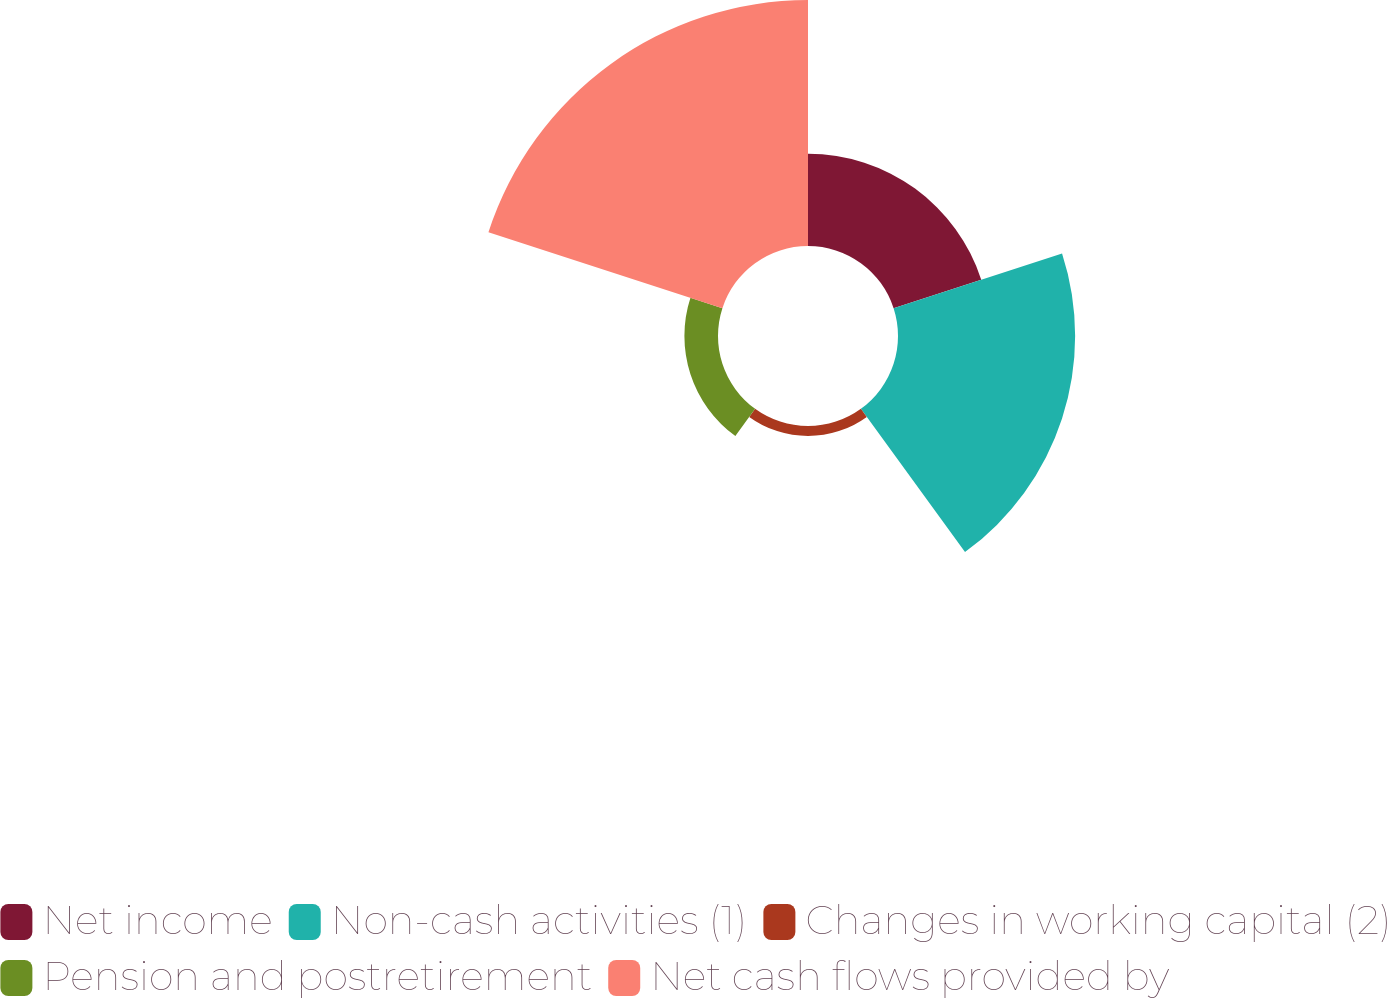<chart> <loc_0><loc_0><loc_500><loc_500><pie_chart><fcel>Net income<fcel>Non-cash activities (1)<fcel>Changes in working capital (2)<fcel>Pension and postretirement<fcel>Net cash flows provided by<nl><fcel>16.49%<fcel>31.69%<fcel>1.79%<fcel>6.01%<fcel>44.01%<nl></chart> 